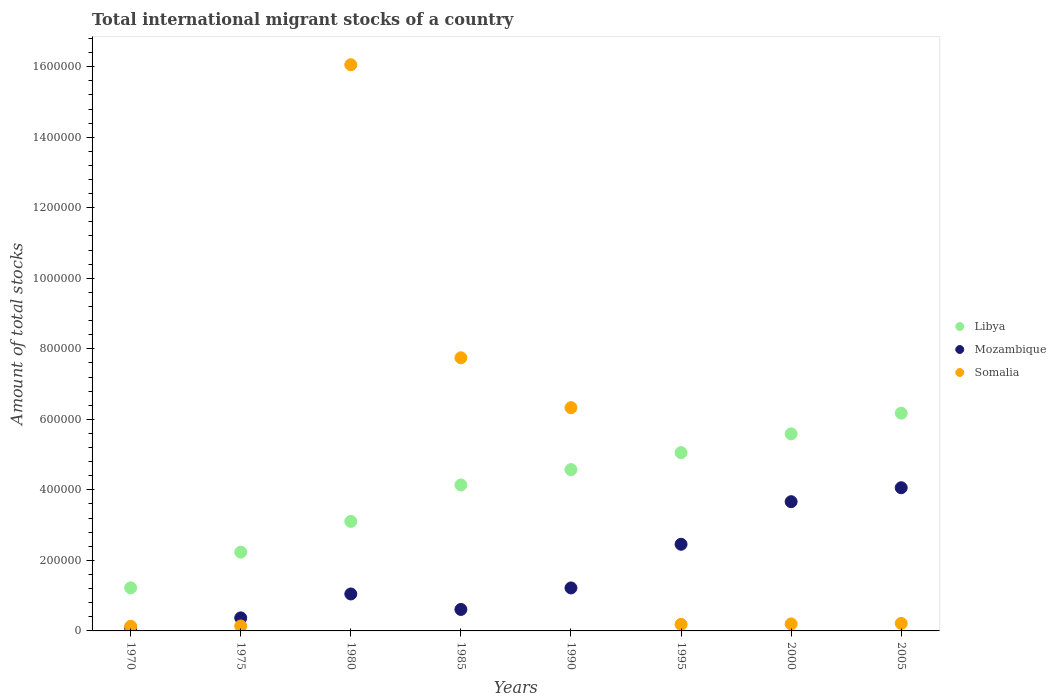Is the number of dotlines equal to the number of legend labels?
Provide a short and direct response. Yes. What is the amount of total stocks in in Mozambique in 1990?
Your answer should be very brief. 1.22e+05. Across all years, what is the maximum amount of total stocks in in Somalia?
Provide a succinct answer. 1.61e+06. Across all years, what is the minimum amount of total stocks in in Somalia?
Provide a succinct answer. 1.30e+04. In which year was the amount of total stocks in in Somalia minimum?
Keep it short and to the point. 1970. What is the total amount of total stocks in in Libya in the graph?
Keep it short and to the point. 3.21e+06. What is the difference between the amount of total stocks in in Somalia in 1980 and that in 1995?
Ensure brevity in your answer.  1.59e+06. What is the difference between the amount of total stocks in in Libya in 1970 and the amount of total stocks in in Somalia in 1980?
Ensure brevity in your answer.  -1.48e+06. What is the average amount of total stocks in in Mozambique per year?
Offer a terse response. 1.69e+05. In the year 2000, what is the difference between the amount of total stocks in in Mozambique and amount of total stocks in in Libya?
Give a very brief answer. -1.92e+05. What is the ratio of the amount of total stocks in in Somalia in 1970 to that in 2005?
Give a very brief answer. 0.61. Is the difference between the amount of total stocks in in Mozambique in 1990 and 2005 greater than the difference between the amount of total stocks in in Libya in 1990 and 2005?
Keep it short and to the point. No. What is the difference between the highest and the second highest amount of total stocks in in Somalia?
Your answer should be compact. 8.31e+05. What is the difference between the highest and the lowest amount of total stocks in in Libya?
Your answer should be very brief. 4.95e+05. In how many years, is the amount of total stocks in in Libya greater than the average amount of total stocks in in Libya taken over all years?
Provide a succinct answer. 5. Is it the case that in every year, the sum of the amount of total stocks in in Somalia and amount of total stocks in in Libya  is greater than the amount of total stocks in in Mozambique?
Give a very brief answer. Yes. Does the amount of total stocks in in Somalia monotonically increase over the years?
Keep it short and to the point. No. Is the amount of total stocks in in Mozambique strictly less than the amount of total stocks in in Somalia over the years?
Provide a short and direct response. No. How many dotlines are there?
Ensure brevity in your answer.  3. How many years are there in the graph?
Your response must be concise. 8. Does the graph contain any zero values?
Make the answer very short. No. Does the graph contain grids?
Your answer should be very brief. No. How many legend labels are there?
Provide a succinct answer. 3. What is the title of the graph?
Give a very brief answer. Total international migrant stocks of a country. What is the label or title of the Y-axis?
Provide a succinct answer. Amount of total stocks. What is the Amount of total stocks of Libya in 1970?
Your response must be concise. 1.22e+05. What is the Amount of total stocks of Mozambique in 1970?
Make the answer very short. 7791. What is the Amount of total stocks in Somalia in 1970?
Your answer should be compact. 1.30e+04. What is the Amount of total stocks of Libya in 1975?
Ensure brevity in your answer.  2.23e+05. What is the Amount of total stocks of Mozambique in 1975?
Offer a very short reply. 3.70e+04. What is the Amount of total stocks in Somalia in 1975?
Your response must be concise. 1.40e+04. What is the Amount of total stocks in Libya in 1980?
Ensure brevity in your answer.  3.11e+05. What is the Amount of total stocks of Mozambique in 1980?
Give a very brief answer. 1.05e+05. What is the Amount of total stocks of Somalia in 1980?
Your answer should be very brief. 1.61e+06. What is the Amount of total stocks of Libya in 1985?
Provide a succinct answer. 4.14e+05. What is the Amount of total stocks of Mozambique in 1985?
Ensure brevity in your answer.  6.09e+04. What is the Amount of total stocks in Somalia in 1985?
Ensure brevity in your answer.  7.75e+05. What is the Amount of total stocks of Libya in 1990?
Provide a short and direct response. 4.57e+05. What is the Amount of total stocks of Mozambique in 1990?
Give a very brief answer. 1.22e+05. What is the Amount of total stocks in Somalia in 1990?
Your response must be concise. 6.33e+05. What is the Amount of total stocks of Libya in 1995?
Ensure brevity in your answer.  5.06e+05. What is the Amount of total stocks in Mozambique in 1995?
Your response must be concise. 2.46e+05. What is the Amount of total stocks of Somalia in 1995?
Offer a terse response. 1.86e+04. What is the Amount of total stocks in Libya in 2000?
Provide a short and direct response. 5.59e+05. What is the Amount of total stocks of Mozambique in 2000?
Make the answer very short. 3.66e+05. What is the Amount of total stocks in Somalia in 2000?
Your answer should be very brief. 1.99e+04. What is the Amount of total stocks of Libya in 2005?
Your response must be concise. 6.18e+05. What is the Amount of total stocks of Mozambique in 2005?
Your answer should be compact. 4.06e+05. What is the Amount of total stocks of Somalia in 2005?
Provide a short and direct response. 2.13e+04. Across all years, what is the maximum Amount of total stocks in Libya?
Offer a very short reply. 6.18e+05. Across all years, what is the maximum Amount of total stocks of Mozambique?
Provide a succinct answer. 4.06e+05. Across all years, what is the maximum Amount of total stocks in Somalia?
Give a very brief answer. 1.61e+06. Across all years, what is the minimum Amount of total stocks of Libya?
Your response must be concise. 1.22e+05. Across all years, what is the minimum Amount of total stocks of Mozambique?
Ensure brevity in your answer.  7791. Across all years, what is the minimum Amount of total stocks in Somalia?
Offer a very short reply. 1.30e+04. What is the total Amount of total stocks of Libya in the graph?
Ensure brevity in your answer.  3.21e+06. What is the total Amount of total stocks in Mozambique in the graph?
Your answer should be compact. 1.35e+06. What is the total Amount of total stocks of Somalia in the graph?
Make the answer very short. 3.10e+06. What is the difference between the Amount of total stocks in Libya in 1970 and that in 1975?
Your response must be concise. -1.01e+05. What is the difference between the Amount of total stocks in Mozambique in 1970 and that in 1975?
Make the answer very short. -2.92e+04. What is the difference between the Amount of total stocks in Somalia in 1970 and that in 1975?
Keep it short and to the point. -1007. What is the difference between the Amount of total stocks of Libya in 1970 and that in 1980?
Offer a very short reply. -1.88e+05. What is the difference between the Amount of total stocks in Mozambique in 1970 and that in 1980?
Provide a succinct answer. -9.70e+04. What is the difference between the Amount of total stocks in Somalia in 1970 and that in 1980?
Your answer should be very brief. -1.59e+06. What is the difference between the Amount of total stocks in Libya in 1970 and that in 1985?
Provide a succinct answer. -2.92e+05. What is the difference between the Amount of total stocks in Mozambique in 1970 and that in 1985?
Ensure brevity in your answer.  -5.31e+04. What is the difference between the Amount of total stocks in Somalia in 1970 and that in 1985?
Provide a succinct answer. -7.62e+05. What is the difference between the Amount of total stocks of Libya in 1970 and that in 1990?
Ensure brevity in your answer.  -3.35e+05. What is the difference between the Amount of total stocks in Mozambique in 1970 and that in 1990?
Offer a terse response. -1.14e+05. What is the difference between the Amount of total stocks in Somalia in 1970 and that in 1990?
Offer a terse response. -6.20e+05. What is the difference between the Amount of total stocks of Libya in 1970 and that in 1995?
Your answer should be very brief. -3.83e+05. What is the difference between the Amount of total stocks of Mozambique in 1970 and that in 1995?
Your answer should be compact. -2.38e+05. What is the difference between the Amount of total stocks of Somalia in 1970 and that in 1995?
Give a very brief answer. -5603. What is the difference between the Amount of total stocks in Libya in 1970 and that in 2000?
Your answer should be compact. -4.37e+05. What is the difference between the Amount of total stocks in Mozambique in 1970 and that in 2000?
Offer a very short reply. -3.59e+05. What is the difference between the Amount of total stocks of Somalia in 1970 and that in 2000?
Keep it short and to the point. -6832. What is the difference between the Amount of total stocks of Libya in 1970 and that in 2005?
Your answer should be compact. -4.95e+05. What is the difference between the Amount of total stocks in Mozambique in 1970 and that in 2005?
Give a very brief answer. -3.98e+05. What is the difference between the Amount of total stocks of Somalia in 1970 and that in 2005?
Offer a terse response. -8230. What is the difference between the Amount of total stocks of Libya in 1975 and that in 1980?
Offer a terse response. -8.72e+04. What is the difference between the Amount of total stocks in Mozambique in 1975 and that in 1980?
Offer a very short reply. -6.78e+04. What is the difference between the Amount of total stocks in Somalia in 1975 and that in 1980?
Offer a terse response. -1.59e+06. What is the difference between the Amount of total stocks of Libya in 1975 and that in 1985?
Offer a terse response. -1.91e+05. What is the difference between the Amount of total stocks in Mozambique in 1975 and that in 1985?
Offer a terse response. -2.39e+04. What is the difference between the Amount of total stocks in Somalia in 1975 and that in 1985?
Your answer should be compact. -7.61e+05. What is the difference between the Amount of total stocks of Libya in 1975 and that in 1990?
Ensure brevity in your answer.  -2.34e+05. What is the difference between the Amount of total stocks in Mozambique in 1975 and that in 1990?
Ensure brevity in your answer.  -8.49e+04. What is the difference between the Amount of total stocks of Somalia in 1975 and that in 1990?
Make the answer very short. -6.19e+05. What is the difference between the Amount of total stocks of Libya in 1975 and that in 1995?
Offer a very short reply. -2.82e+05. What is the difference between the Amount of total stocks of Mozambique in 1975 and that in 1995?
Keep it short and to the point. -2.09e+05. What is the difference between the Amount of total stocks in Somalia in 1975 and that in 1995?
Provide a short and direct response. -4596. What is the difference between the Amount of total stocks of Libya in 1975 and that in 2000?
Give a very brief answer. -3.35e+05. What is the difference between the Amount of total stocks in Mozambique in 1975 and that in 2000?
Provide a short and direct response. -3.29e+05. What is the difference between the Amount of total stocks in Somalia in 1975 and that in 2000?
Offer a very short reply. -5825. What is the difference between the Amount of total stocks in Libya in 1975 and that in 2005?
Offer a terse response. -3.94e+05. What is the difference between the Amount of total stocks of Mozambique in 1975 and that in 2005?
Your response must be concise. -3.69e+05. What is the difference between the Amount of total stocks in Somalia in 1975 and that in 2005?
Keep it short and to the point. -7223. What is the difference between the Amount of total stocks in Libya in 1980 and that in 1985?
Give a very brief answer. -1.03e+05. What is the difference between the Amount of total stocks of Mozambique in 1980 and that in 1985?
Provide a succinct answer. 4.39e+04. What is the difference between the Amount of total stocks in Somalia in 1980 and that in 1985?
Your answer should be very brief. 8.31e+05. What is the difference between the Amount of total stocks of Libya in 1980 and that in 1990?
Your answer should be very brief. -1.47e+05. What is the difference between the Amount of total stocks in Mozambique in 1980 and that in 1990?
Ensure brevity in your answer.  -1.71e+04. What is the difference between the Amount of total stocks of Somalia in 1980 and that in 1990?
Offer a very short reply. 9.73e+05. What is the difference between the Amount of total stocks of Libya in 1980 and that in 1995?
Offer a very short reply. -1.95e+05. What is the difference between the Amount of total stocks of Mozambique in 1980 and that in 1995?
Your response must be concise. -1.41e+05. What is the difference between the Amount of total stocks of Somalia in 1980 and that in 1995?
Keep it short and to the point. 1.59e+06. What is the difference between the Amount of total stocks in Libya in 1980 and that in 2000?
Your answer should be compact. -2.48e+05. What is the difference between the Amount of total stocks of Mozambique in 1980 and that in 2000?
Ensure brevity in your answer.  -2.62e+05. What is the difference between the Amount of total stocks of Somalia in 1980 and that in 2000?
Offer a very short reply. 1.59e+06. What is the difference between the Amount of total stocks of Libya in 1980 and that in 2005?
Keep it short and to the point. -3.07e+05. What is the difference between the Amount of total stocks in Mozambique in 1980 and that in 2005?
Provide a short and direct response. -3.01e+05. What is the difference between the Amount of total stocks in Somalia in 1980 and that in 2005?
Provide a succinct answer. 1.58e+06. What is the difference between the Amount of total stocks in Libya in 1985 and that in 1990?
Make the answer very short. -4.35e+04. What is the difference between the Amount of total stocks in Mozambique in 1985 and that in 1990?
Your answer should be compact. -6.10e+04. What is the difference between the Amount of total stocks of Somalia in 1985 and that in 1990?
Offer a terse response. 1.41e+05. What is the difference between the Amount of total stocks of Libya in 1985 and that in 1995?
Your response must be concise. -9.16e+04. What is the difference between the Amount of total stocks in Mozambique in 1985 and that in 1995?
Offer a very short reply. -1.85e+05. What is the difference between the Amount of total stocks in Somalia in 1985 and that in 1995?
Your answer should be compact. 7.56e+05. What is the difference between the Amount of total stocks in Libya in 1985 and that in 2000?
Your response must be concise. -1.45e+05. What is the difference between the Amount of total stocks of Mozambique in 1985 and that in 2000?
Offer a terse response. -3.06e+05. What is the difference between the Amount of total stocks in Somalia in 1985 and that in 2000?
Give a very brief answer. 7.55e+05. What is the difference between the Amount of total stocks of Libya in 1985 and that in 2005?
Your answer should be compact. -2.04e+05. What is the difference between the Amount of total stocks in Mozambique in 1985 and that in 2005?
Your answer should be compact. -3.45e+05. What is the difference between the Amount of total stocks in Somalia in 1985 and that in 2005?
Your answer should be compact. 7.53e+05. What is the difference between the Amount of total stocks of Libya in 1990 and that in 1995?
Offer a very short reply. -4.81e+04. What is the difference between the Amount of total stocks of Mozambique in 1990 and that in 1995?
Offer a terse response. -1.24e+05. What is the difference between the Amount of total stocks of Somalia in 1990 and that in 1995?
Give a very brief answer. 6.14e+05. What is the difference between the Amount of total stocks in Libya in 1990 and that in 2000?
Ensure brevity in your answer.  -1.01e+05. What is the difference between the Amount of total stocks in Mozambique in 1990 and that in 2000?
Offer a very short reply. -2.45e+05. What is the difference between the Amount of total stocks in Somalia in 1990 and that in 2000?
Provide a succinct answer. 6.13e+05. What is the difference between the Amount of total stocks of Libya in 1990 and that in 2005?
Offer a terse response. -1.60e+05. What is the difference between the Amount of total stocks in Mozambique in 1990 and that in 2005?
Give a very brief answer. -2.84e+05. What is the difference between the Amount of total stocks in Somalia in 1990 and that in 2005?
Your answer should be compact. 6.12e+05. What is the difference between the Amount of total stocks of Libya in 1995 and that in 2000?
Your response must be concise. -5.32e+04. What is the difference between the Amount of total stocks in Mozambique in 1995 and that in 2000?
Offer a terse response. -1.21e+05. What is the difference between the Amount of total stocks in Somalia in 1995 and that in 2000?
Provide a short and direct response. -1229. What is the difference between the Amount of total stocks of Libya in 1995 and that in 2005?
Give a very brief answer. -1.12e+05. What is the difference between the Amount of total stocks of Mozambique in 1995 and that in 2005?
Provide a succinct answer. -1.60e+05. What is the difference between the Amount of total stocks of Somalia in 1995 and that in 2005?
Your response must be concise. -2627. What is the difference between the Amount of total stocks in Libya in 2000 and that in 2005?
Keep it short and to the point. -5.88e+04. What is the difference between the Amount of total stocks of Mozambique in 2000 and that in 2005?
Your answer should be very brief. -3.96e+04. What is the difference between the Amount of total stocks of Somalia in 2000 and that in 2005?
Provide a short and direct response. -1398. What is the difference between the Amount of total stocks in Libya in 1970 and the Amount of total stocks in Mozambique in 1975?
Ensure brevity in your answer.  8.52e+04. What is the difference between the Amount of total stocks in Libya in 1970 and the Amount of total stocks in Somalia in 1975?
Ensure brevity in your answer.  1.08e+05. What is the difference between the Amount of total stocks of Mozambique in 1970 and the Amount of total stocks of Somalia in 1975?
Offer a terse response. -6257. What is the difference between the Amount of total stocks of Libya in 1970 and the Amount of total stocks of Mozambique in 1980?
Offer a terse response. 1.74e+04. What is the difference between the Amount of total stocks of Libya in 1970 and the Amount of total stocks of Somalia in 1980?
Give a very brief answer. -1.48e+06. What is the difference between the Amount of total stocks in Mozambique in 1970 and the Amount of total stocks in Somalia in 1980?
Make the answer very short. -1.60e+06. What is the difference between the Amount of total stocks of Libya in 1970 and the Amount of total stocks of Mozambique in 1985?
Keep it short and to the point. 6.13e+04. What is the difference between the Amount of total stocks of Libya in 1970 and the Amount of total stocks of Somalia in 1985?
Provide a succinct answer. -6.52e+05. What is the difference between the Amount of total stocks of Mozambique in 1970 and the Amount of total stocks of Somalia in 1985?
Keep it short and to the point. -7.67e+05. What is the difference between the Amount of total stocks in Libya in 1970 and the Amount of total stocks in Mozambique in 1990?
Offer a terse response. 255. What is the difference between the Amount of total stocks in Libya in 1970 and the Amount of total stocks in Somalia in 1990?
Offer a terse response. -5.11e+05. What is the difference between the Amount of total stocks in Mozambique in 1970 and the Amount of total stocks in Somalia in 1990?
Your answer should be very brief. -6.25e+05. What is the difference between the Amount of total stocks in Libya in 1970 and the Amount of total stocks in Mozambique in 1995?
Ensure brevity in your answer.  -1.24e+05. What is the difference between the Amount of total stocks in Libya in 1970 and the Amount of total stocks in Somalia in 1995?
Make the answer very short. 1.04e+05. What is the difference between the Amount of total stocks of Mozambique in 1970 and the Amount of total stocks of Somalia in 1995?
Ensure brevity in your answer.  -1.09e+04. What is the difference between the Amount of total stocks of Libya in 1970 and the Amount of total stocks of Mozambique in 2000?
Provide a succinct answer. -2.44e+05. What is the difference between the Amount of total stocks of Libya in 1970 and the Amount of total stocks of Somalia in 2000?
Keep it short and to the point. 1.02e+05. What is the difference between the Amount of total stocks of Mozambique in 1970 and the Amount of total stocks of Somalia in 2000?
Offer a terse response. -1.21e+04. What is the difference between the Amount of total stocks of Libya in 1970 and the Amount of total stocks of Mozambique in 2005?
Offer a terse response. -2.84e+05. What is the difference between the Amount of total stocks in Libya in 1970 and the Amount of total stocks in Somalia in 2005?
Your response must be concise. 1.01e+05. What is the difference between the Amount of total stocks in Mozambique in 1970 and the Amount of total stocks in Somalia in 2005?
Offer a terse response. -1.35e+04. What is the difference between the Amount of total stocks of Libya in 1975 and the Amount of total stocks of Mozambique in 1980?
Provide a succinct answer. 1.19e+05. What is the difference between the Amount of total stocks of Libya in 1975 and the Amount of total stocks of Somalia in 1980?
Give a very brief answer. -1.38e+06. What is the difference between the Amount of total stocks of Mozambique in 1975 and the Amount of total stocks of Somalia in 1980?
Offer a terse response. -1.57e+06. What is the difference between the Amount of total stocks of Libya in 1975 and the Amount of total stocks of Mozambique in 1985?
Provide a short and direct response. 1.63e+05. What is the difference between the Amount of total stocks in Libya in 1975 and the Amount of total stocks in Somalia in 1985?
Provide a succinct answer. -5.51e+05. What is the difference between the Amount of total stocks of Mozambique in 1975 and the Amount of total stocks of Somalia in 1985?
Your response must be concise. -7.38e+05. What is the difference between the Amount of total stocks in Libya in 1975 and the Amount of total stocks in Mozambique in 1990?
Your response must be concise. 1.01e+05. What is the difference between the Amount of total stocks in Libya in 1975 and the Amount of total stocks in Somalia in 1990?
Offer a very short reply. -4.10e+05. What is the difference between the Amount of total stocks in Mozambique in 1975 and the Amount of total stocks in Somalia in 1990?
Provide a succinct answer. -5.96e+05. What is the difference between the Amount of total stocks in Libya in 1975 and the Amount of total stocks in Mozambique in 1995?
Your response must be concise. -2.23e+04. What is the difference between the Amount of total stocks of Libya in 1975 and the Amount of total stocks of Somalia in 1995?
Your response must be concise. 2.05e+05. What is the difference between the Amount of total stocks of Mozambique in 1975 and the Amount of total stocks of Somalia in 1995?
Provide a succinct answer. 1.84e+04. What is the difference between the Amount of total stocks in Libya in 1975 and the Amount of total stocks in Mozambique in 2000?
Your answer should be very brief. -1.43e+05. What is the difference between the Amount of total stocks of Libya in 1975 and the Amount of total stocks of Somalia in 2000?
Provide a succinct answer. 2.04e+05. What is the difference between the Amount of total stocks of Mozambique in 1975 and the Amount of total stocks of Somalia in 2000?
Offer a very short reply. 1.71e+04. What is the difference between the Amount of total stocks of Libya in 1975 and the Amount of total stocks of Mozambique in 2005?
Your response must be concise. -1.83e+05. What is the difference between the Amount of total stocks in Libya in 1975 and the Amount of total stocks in Somalia in 2005?
Your answer should be very brief. 2.02e+05. What is the difference between the Amount of total stocks of Mozambique in 1975 and the Amount of total stocks of Somalia in 2005?
Keep it short and to the point. 1.57e+04. What is the difference between the Amount of total stocks in Libya in 1980 and the Amount of total stocks in Mozambique in 1985?
Your answer should be very brief. 2.50e+05. What is the difference between the Amount of total stocks in Libya in 1980 and the Amount of total stocks in Somalia in 1985?
Give a very brief answer. -4.64e+05. What is the difference between the Amount of total stocks in Mozambique in 1980 and the Amount of total stocks in Somalia in 1985?
Your answer should be compact. -6.70e+05. What is the difference between the Amount of total stocks of Libya in 1980 and the Amount of total stocks of Mozambique in 1990?
Provide a short and direct response. 1.89e+05. What is the difference between the Amount of total stocks of Libya in 1980 and the Amount of total stocks of Somalia in 1990?
Keep it short and to the point. -3.23e+05. What is the difference between the Amount of total stocks of Mozambique in 1980 and the Amount of total stocks of Somalia in 1990?
Keep it short and to the point. -5.28e+05. What is the difference between the Amount of total stocks in Libya in 1980 and the Amount of total stocks in Mozambique in 1995?
Your response must be concise. 6.48e+04. What is the difference between the Amount of total stocks in Libya in 1980 and the Amount of total stocks in Somalia in 1995?
Keep it short and to the point. 2.92e+05. What is the difference between the Amount of total stocks in Mozambique in 1980 and the Amount of total stocks in Somalia in 1995?
Your answer should be very brief. 8.62e+04. What is the difference between the Amount of total stocks in Libya in 1980 and the Amount of total stocks in Mozambique in 2000?
Your answer should be very brief. -5.59e+04. What is the difference between the Amount of total stocks of Libya in 1980 and the Amount of total stocks of Somalia in 2000?
Make the answer very short. 2.91e+05. What is the difference between the Amount of total stocks of Mozambique in 1980 and the Amount of total stocks of Somalia in 2000?
Your answer should be compact. 8.49e+04. What is the difference between the Amount of total stocks of Libya in 1980 and the Amount of total stocks of Mozambique in 2005?
Give a very brief answer. -9.55e+04. What is the difference between the Amount of total stocks of Libya in 1980 and the Amount of total stocks of Somalia in 2005?
Offer a terse response. 2.89e+05. What is the difference between the Amount of total stocks in Mozambique in 1980 and the Amount of total stocks in Somalia in 2005?
Make the answer very short. 8.35e+04. What is the difference between the Amount of total stocks of Libya in 1985 and the Amount of total stocks of Mozambique in 1990?
Offer a terse response. 2.92e+05. What is the difference between the Amount of total stocks of Libya in 1985 and the Amount of total stocks of Somalia in 1990?
Offer a very short reply. -2.19e+05. What is the difference between the Amount of total stocks in Mozambique in 1985 and the Amount of total stocks in Somalia in 1990?
Offer a very short reply. -5.72e+05. What is the difference between the Amount of total stocks of Libya in 1985 and the Amount of total stocks of Mozambique in 1995?
Provide a short and direct response. 1.68e+05. What is the difference between the Amount of total stocks in Libya in 1985 and the Amount of total stocks in Somalia in 1995?
Offer a very short reply. 3.95e+05. What is the difference between the Amount of total stocks in Mozambique in 1985 and the Amount of total stocks in Somalia in 1995?
Offer a terse response. 4.22e+04. What is the difference between the Amount of total stocks of Libya in 1985 and the Amount of total stocks of Mozambique in 2000?
Your response must be concise. 4.75e+04. What is the difference between the Amount of total stocks of Libya in 1985 and the Amount of total stocks of Somalia in 2000?
Keep it short and to the point. 3.94e+05. What is the difference between the Amount of total stocks in Mozambique in 1985 and the Amount of total stocks in Somalia in 2000?
Make the answer very short. 4.10e+04. What is the difference between the Amount of total stocks in Libya in 1985 and the Amount of total stocks in Mozambique in 2005?
Ensure brevity in your answer.  7872. What is the difference between the Amount of total stocks of Libya in 1985 and the Amount of total stocks of Somalia in 2005?
Your answer should be compact. 3.93e+05. What is the difference between the Amount of total stocks in Mozambique in 1985 and the Amount of total stocks in Somalia in 2005?
Give a very brief answer. 3.96e+04. What is the difference between the Amount of total stocks of Libya in 1990 and the Amount of total stocks of Mozambique in 1995?
Keep it short and to the point. 2.12e+05. What is the difference between the Amount of total stocks of Libya in 1990 and the Amount of total stocks of Somalia in 1995?
Keep it short and to the point. 4.39e+05. What is the difference between the Amount of total stocks in Mozambique in 1990 and the Amount of total stocks in Somalia in 1995?
Offer a very short reply. 1.03e+05. What is the difference between the Amount of total stocks of Libya in 1990 and the Amount of total stocks of Mozambique in 2000?
Provide a short and direct response. 9.10e+04. What is the difference between the Amount of total stocks in Libya in 1990 and the Amount of total stocks in Somalia in 2000?
Keep it short and to the point. 4.38e+05. What is the difference between the Amount of total stocks of Mozambique in 1990 and the Amount of total stocks of Somalia in 2000?
Keep it short and to the point. 1.02e+05. What is the difference between the Amount of total stocks in Libya in 1990 and the Amount of total stocks in Mozambique in 2005?
Keep it short and to the point. 5.14e+04. What is the difference between the Amount of total stocks in Libya in 1990 and the Amount of total stocks in Somalia in 2005?
Give a very brief answer. 4.36e+05. What is the difference between the Amount of total stocks in Mozambique in 1990 and the Amount of total stocks in Somalia in 2005?
Your answer should be very brief. 1.01e+05. What is the difference between the Amount of total stocks in Libya in 1995 and the Amount of total stocks in Mozambique in 2000?
Give a very brief answer. 1.39e+05. What is the difference between the Amount of total stocks in Libya in 1995 and the Amount of total stocks in Somalia in 2000?
Make the answer very short. 4.86e+05. What is the difference between the Amount of total stocks in Mozambique in 1995 and the Amount of total stocks in Somalia in 2000?
Your response must be concise. 2.26e+05. What is the difference between the Amount of total stocks in Libya in 1995 and the Amount of total stocks in Mozambique in 2005?
Offer a very short reply. 9.95e+04. What is the difference between the Amount of total stocks in Libya in 1995 and the Amount of total stocks in Somalia in 2005?
Give a very brief answer. 4.84e+05. What is the difference between the Amount of total stocks of Mozambique in 1995 and the Amount of total stocks of Somalia in 2005?
Offer a terse response. 2.24e+05. What is the difference between the Amount of total stocks of Libya in 2000 and the Amount of total stocks of Mozambique in 2005?
Provide a short and direct response. 1.53e+05. What is the difference between the Amount of total stocks in Libya in 2000 and the Amount of total stocks in Somalia in 2005?
Your answer should be compact. 5.37e+05. What is the difference between the Amount of total stocks in Mozambique in 2000 and the Amount of total stocks in Somalia in 2005?
Make the answer very short. 3.45e+05. What is the average Amount of total stocks in Libya per year?
Make the answer very short. 4.01e+05. What is the average Amount of total stocks of Mozambique per year?
Offer a very short reply. 1.69e+05. What is the average Amount of total stocks of Somalia per year?
Your answer should be compact. 3.88e+05. In the year 1970, what is the difference between the Amount of total stocks in Libya and Amount of total stocks in Mozambique?
Your answer should be very brief. 1.14e+05. In the year 1970, what is the difference between the Amount of total stocks in Libya and Amount of total stocks in Somalia?
Provide a succinct answer. 1.09e+05. In the year 1970, what is the difference between the Amount of total stocks in Mozambique and Amount of total stocks in Somalia?
Your answer should be compact. -5250. In the year 1975, what is the difference between the Amount of total stocks in Libya and Amount of total stocks in Mozambique?
Keep it short and to the point. 1.86e+05. In the year 1975, what is the difference between the Amount of total stocks of Libya and Amount of total stocks of Somalia?
Provide a short and direct response. 2.09e+05. In the year 1975, what is the difference between the Amount of total stocks of Mozambique and Amount of total stocks of Somalia?
Offer a very short reply. 2.30e+04. In the year 1980, what is the difference between the Amount of total stocks in Libya and Amount of total stocks in Mozambique?
Offer a very short reply. 2.06e+05. In the year 1980, what is the difference between the Amount of total stocks of Libya and Amount of total stocks of Somalia?
Make the answer very short. -1.30e+06. In the year 1980, what is the difference between the Amount of total stocks of Mozambique and Amount of total stocks of Somalia?
Make the answer very short. -1.50e+06. In the year 1985, what is the difference between the Amount of total stocks in Libya and Amount of total stocks in Mozambique?
Offer a terse response. 3.53e+05. In the year 1985, what is the difference between the Amount of total stocks of Libya and Amount of total stocks of Somalia?
Your answer should be compact. -3.61e+05. In the year 1985, what is the difference between the Amount of total stocks in Mozambique and Amount of total stocks in Somalia?
Your answer should be compact. -7.14e+05. In the year 1990, what is the difference between the Amount of total stocks of Libya and Amount of total stocks of Mozambique?
Ensure brevity in your answer.  3.36e+05. In the year 1990, what is the difference between the Amount of total stocks in Libya and Amount of total stocks in Somalia?
Offer a very short reply. -1.76e+05. In the year 1990, what is the difference between the Amount of total stocks in Mozambique and Amount of total stocks in Somalia?
Your answer should be compact. -5.11e+05. In the year 1995, what is the difference between the Amount of total stocks of Libya and Amount of total stocks of Mozambique?
Keep it short and to the point. 2.60e+05. In the year 1995, what is the difference between the Amount of total stocks in Libya and Amount of total stocks in Somalia?
Provide a succinct answer. 4.87e+05. In the year 1995, what is the difference between the Amount of total stocks in Mozambique and Amount of total stocks in Somalia?
Keep it short and to the point. 2.27e+05. In the year 2000, what is the difference between the Amount of total stocks in Libya and Amount of total stocks in Mozambique?
Your answer should be compact. 1.92e+05. In the year 2000, what is the difference between the Amount of total stocks in Libya and Amount of total stocks in Somalia?
Give a very brief answer. 5.39e+05. In the year 2000, what is the difference between the Amount of total stocks in Mozambique and Amount of total stocks in Somalia?
Give a very brief answer. 3.47e+05. In the year 2005, what is the difference between the Amount of total stocks in Libya and Amount of total stocks in Mozambique?
Your response must be concise. 2.11e+05. In the year 2005, what is the difference between the Amount of total stocks of Libya and Amount of total stocks of Somalia?
Your answer should be very brief. 5.96e+05. In the year 2005, what is the difference between the Amount of total stocks in Mozambique and Amount of total stocks in Somalia?
Give a very brief answer. 3.85e+05. What is the ratio of the Amount of total stocks of Libya in 1970 to that in 1975?
Keep it short and to the point. 0.55. What is the ratio of the Amount of total stocks of Mozambique in 1970 to that in 1975?
Make the answer very short. 0.21. What is the ratio of the Amount of total stocks in Somalia in 1970 to that in 1975?
Offer a terse response. 0.93. What is the ratio of the Amount of total stocks in Libya in 1970 to that in 1980?
Offer a very short reply. 0.39. What is the ratio of the Amount of total stocks of Mozambique in 1970 to that in 1980?
Keep it short and to the point. 0.07. What is the ratio of the Amount of total stocks in Somalia in 1970 to that in 1980?
Your answer should be very brief. 0.01. What is the ratio of the Amount of total stocks of Libya in 1970 to that in 1985?
Your answer should be very brief. 0.3. What is the ratio of the Amount of total stocks in Mozambique in 1970 to that in 1985?
Your answer should be compact. 0.13. What is the ratio of the Amount of total stocks of Somalia in 1970 to that in 1985?
Ensure brevity in your answer.  0.02. What is the ratio of the Amount of total stocks of Libya in 1970 to that in 1990?
Offer a terse response. 0.27. What is the ratio of the Amount of total stocks in Mozambique in 1970 to that in 1990?
Your answer should be compact. 0.06. What is the ratio of the Amount of total stocks in Somalia in 1970 to that in 1990?
Your response must be concise. 0.02. What is the ratio of the Amount of total stocks in Libya in 1970 to that in 1995?
Your response must be concise. 0.24. What is the ratio of the Amount of total stocks of Mozambique in 1970 to that in 1995?
Provide a succinct answer. 0.03. What is the ratio of the Amount of total stocks of Somalia in 1970 to that in 1995?
Your answer should be very brief. 0.7. What is the ratio of the Amount of total stocks of Libya in 1970 to that in 2000?
Provide a short and direct response. 0.22. What is the ratio of the Amount of total stocks of Mozambique in 1970 to that in 2000?
Your answer should be compact. 0.02. What is the ratio of the Amount of total stocks in Somalia in 1970 to that in 2000?
Offer a terse response. 0.66. What is the ratio of the Amount of total stocks in Libya in 1970 to that in 2005?
Offer a very short reply. 0.2. What is the ratio of the Amount of total stocks of Mozambique in 1970 to that in 2005?
Provide a succinct answer. 0.02. What is the ratio of the Amount of total stocks in Somalia in 1970 to that in 2005?
Provide a succinct answer. 0.61. What is the ratio of the Amount of total stocks of Libya in 1975 to that in 1980?
Your response must be concise. 0.72. What is the ratio of the Amount of total stocks of Mozambique in 1975 to that in 1980?
Your response must be concise. 0.35. What is the ratio of the Amount of total stocks of Somalia in 1975 to that in 1980?
Ensure brevity in your answer.  0.01. What is the ratio of the Amount of total stocks of Libya in 1975 to that in 1985?
Make the answer very short. 0.54. What is the ratio of the Amount of total stocks in Mozambique in 1975 to that in 1985?
Keep it short and to the point. 0.61. What is the ratio of the Amount of total stocks in Somalia in 1975 to that in 1985?
Your response must be concise. 0.02. What is the ratio of the Amount of total stocks of Libya in 1975 to that in 1990?
Offer a terse response. 0.49. What is the ratio of the Amount of total stocks of Mozambique in 1975 to that in 1990?
Ensure brevity in your answer.  0.3. What is the ratio of the Amount of total stocks in Somalia in 1975 to that in 1990?
Make the answer very short. 0.02. What is the ratio of the Amount of total stocks in Libya in 1975 to that in 1995?
Offer a terse response. 0.44. What is the ratio of the Amount of total stocks in Mozambique in 1975 to that in 1995?
Make the answer very short. 0.15. What is the ratio of the Amount of total stocks in Somalia in 1975 to that in 1995?
Your answer should be very brief. 0.75. What is the ratio of the Amount of total stocks in Libya in 1975 to that in 2000?
Your answer should be compact. 0.4. What is the ratio of the Amount of total stocks in Mozambique in 1975 to that in 2000?
Your answer should be very brief. 0.1. What is the ratio of the Amount of total stocks in Somalia in 1975 to that in 2000?
Give a very brief answer. 0.71. What is the ratio of the Amount of total stocks of Libya in 1975 to that in 2005?
Your response must be concise. 0.36. What is the ratio of the Amount of total stocks in Mozambique in 1975 to that in 2005?
Your answer should be very brief. 0.09. What is the ratio of the Amount of total stocks in Somalia in 1975 to that in 2005?
Offer a terse response. 0.66. What is the ratio of the Amount of total stocks in Libya in 1980 to that in 1985?
Offer a very short reply. 0.75. What is the ratio of the Amount of total stocks of Mozambique in 1980 to that in 1985?
Your answer should be compact. 1.72. What is the ratio of the Amount of total stocks in Somalia in 1980 to that in 1985?
Keep it short and to the point. 2.07. What is the ratio of the Amount of total stocks of Libya in 1980 to that in 1990?
Your response must be concise. 0.68. What is the ratio of the Amount of total stocks of Mozambique in 1980 to that in 1990?
Provide a short and direct response. 0.86. What is the ratio of the Amount of total stocks in Somalia in 1980 to that in 1990?
Provide a succinct answer. 2.54. What is the ratio of the Amount of total stocks of Libya in 1980 to that in 1995?
Keep it short and to the point. 0.61. What is the ratio of the Amount of total stocks of Mozambique in 1980 to that in 1995?
Ensure brevity in your answer.  0.43. What is the ratio of the Amount of total stocks in Somalia in 1980 to that in 1995?
Your response must be concise. 86.12. What is the ratio of the Amount of total stocks of Libya in 1980 to that in 2000?
Give a very brief answer. 0.56. What is the ratio of the Amount of total stocks in Mozambique in 1980 to that in 2000?
Give a very brief answer. 0.29. What is the ratio of the Amount of total stocks of Somalia in 1980 to that in 2000?
Make the answer very short. 80.79. What is the ratio of the Amount of total stocks of Libya in 1980 to that in 2005?
Make the answer very short. 0.5. What is the ratio of the Amount of total stocks of Mozambique in 1980 to that in 2005?
Offer a terse response. 0.26. What is the ratio of the Amount of total stocks in Somalia in 1980 to that in 2005?
Your response must be concise. 75.48. What is the ratio of the Amount of total stocks in Libya in 1985 to that in 1990?
Your response must be concise. 0.9. What is the ratio of the Amount of total stocks of Mozambique in 1985 to that in 1990?
Make the answer very short. 0.5. What is the ratio of the Amount of total stocks in Somalia in 1985 to that in 1990?
Your response must be concise. 1.22. What is the ratio of the Amount of total stocks of Libya in 1985 to that in 1995?
Give a very brief answer. 0.82. What is the ratio of the Amount of total stocks in Mozambique in 1985 to that in 1995?
Offer a very short reply. 0.25. What is the ratio of the Amount of total stocks in Somalia in 1985 to that in 1995?
Your answer should be very brief. 41.55. What is the ratio of the Amount of total stocks of Libya in 1985 to that in 2000?
Keep it short and to the point. 0.74. What is the ratio of the Amount of total stocks of Mozambique in 1985 to that in 2000?
Keep it short and to the point. 0.17. What is the ratio of the Amount of total stocks in Somalia in 1985 to that in 2000?
Provide a short and direct response. 38.98. What is the ratio of the Amount of total stocks of Libya in 1985 to that in 2005?
Your answer should be very brief. 0.67. What is the ratio of the Amount of total stocks of Somalia in 1985 to that in 2005?
Provide a succinct answer. 36.41. What is the ratio of the Amount of total stocks of Libya in 1990 to that in 1995?
Give a very brief answer. 0.9. What is the ratio of the Amount of total stocks in Mozambique in 1990 to that in 1995?
Your answer should be compact. 0.5. What is the ratio of the Amount of total stocks in Somalia in 1990 to that in 1995?
Offer a terse response. 33.96. What is the ratio of the Amount of total stocks of Libya in 1990 to that in 2000?
Offer a very short reply. 0.82. What is the ratio of the Amount of total stocks of Mozambique in 1990 to that in 2000?
Your response must be concise. 0.33. What is the ratio of the Amount of total stocks in Somalia in 1990 to that in 2000?
Offer a very short reply. 31.86. What is the ratio of the Amount of total stocks of Libya in 1990 to that in 2005?
Provide a succinct answer. 0.74. What is the ratio of the Amount of total stocks of Mozambique in 1990 to that in 2005?
Your answer should be very brief. 0.3. What is the ratio of the Amount of total stocks of Somalia in 1990 to that in 2005?
Ensure brevity in your answer.  29.76. What is the ratio of the Amount of total stocks in Libya in 1995 to that in 2000?
Ensure brevity in your answer.  0.9. What is the ratio of the Amount of total stocks in Mozambique in 1995 to that in 2000?
Your answer should be very brief. 0.67. What is the ratio of the Amount of total stocks in Somalia in 1995 to that in 2000?
Keep it short and to the point. 0.94. What is the ratio of the Amount of total stocks in Libya in 1995 to that in 2005?
Ensure brevity in your answer.  0.82. What is the ratio of the Amount of total stocks of Mozambique in 1995 to that in 2005?
Make the answer very short. 0.61. What is the ratio of the Amount of total stocks in Somalia in 1995 to that in 2005?
Offer a terse response. 0.88. What is the ratio of the Amount of total stocks of Libya in 2000 to that in 2005?
Give a very brief answer. 0.9. What is the ratio of the Amount of total stocks of Mozambique in 2000 to that in 2005?
Ensure brevity in your answer.  0.9. What is the ratio of the Amount of total stocks in Somalia in 2000 to that in 2005?
Offer a terse response. 0.93. What is the difference between the highest and the second highest Amount of total stocks in Libya?
Your answer should be very brief. 5.88e+04. What is the difference between the highest and the second highest Amount of total stocks of Mozambique?
Your response must be concise. 3.96e+04. What is the difference between the highest and the second highest Amount of total stocks in Somalia?
Your response must be concise. 8.31e+05. What is the difference between the highest and the lowest Amount of total stocks in Libya?
Provide a succinct answer. 4.95e+05. What is the difference between the highest and the lowest Amount of total stocks of Mozambique?
Give a very brief answer. 3.98e+05. What is the difference between the highest and the lowest Amount of total stocks in Somalia?
Offer a very short reply. 1.59e+06. 